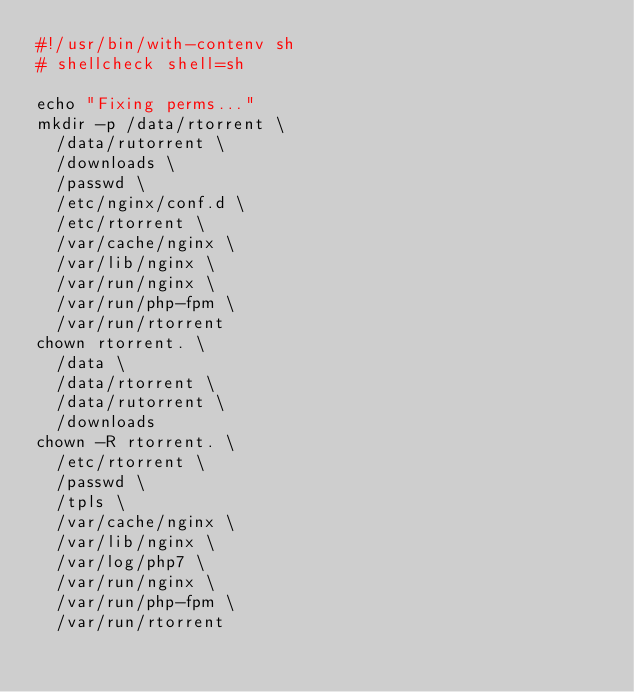Convert code to text. <code><loc_0><loc_0><loc_500><loc_500><_Bash_>#!/usr/bin/with-contenv sh
# shellcheck shell=sh

echo "Fixing perms..."
mkdir -p /data/rtorrent \
  /data/rutorrent \
  /downloads \
  /passwd \
  /etc/nginx/conf.d \
  /etc/rtorrent \
  /var/cache/nginx \
  /var/lib/nginx \
  /var/run/nginx \
  /var/run/php-fpm \
  /var/run/rtorrent
chown rtorrent. \
  /data \
  /data/rtorrent \
  /data/rutorrent \
  /downloads
chown -R rtorrent. \
  /etc/rtorrent \
  /passwd \
  /tpls \
  /var/cache/nginx \
  /var/lib/nginx \
  /var/log/php7 \
  /var/run/nginx \
  /var/run/php-fpm \
  /var/run/rtorrent
</code> 